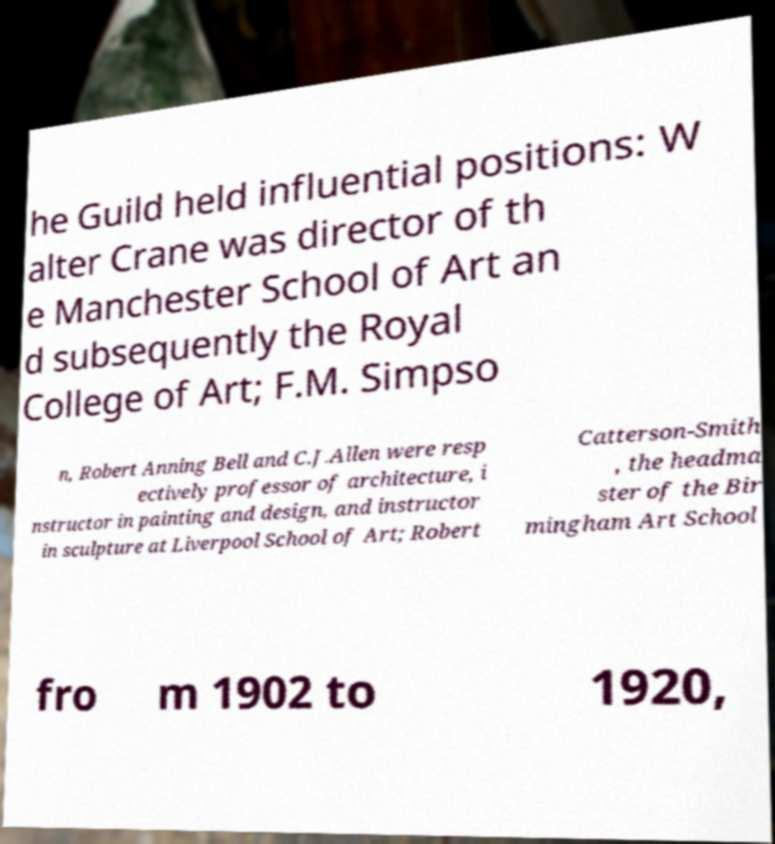Could you extract and type out the text from this image? he Guild held influential positions: W alter Crane was director of th e Manchester School of Art an d subsequently the Royal College of Art; F.M. Simpso n, Robert Anning Bell and C.J.Allen were resp ectively professor of architecture, i nstructor in painting and design, and instructor in sculpture at Liverpool School of Art; Robert Catterson-Smith , the headma ster of the Bir mingham Art School fro m 1902 to 1920, 